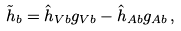Convert formula to latex. <formula><loc_0><loc_0><loc_500><loc_500>\tilde { h } _ { b } = \hat { h } _ { V b } g _ { V b } - \hat { h } _ { A b } g _ { A b } \, ,</formula> 